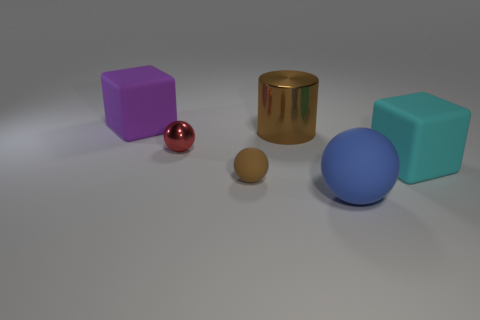What number of other things are there of the same color as the tiny matte object? There appears to be one other object of the same color as the tiny matte brown sphere. It's the larger, also matte, brown cylinder. 